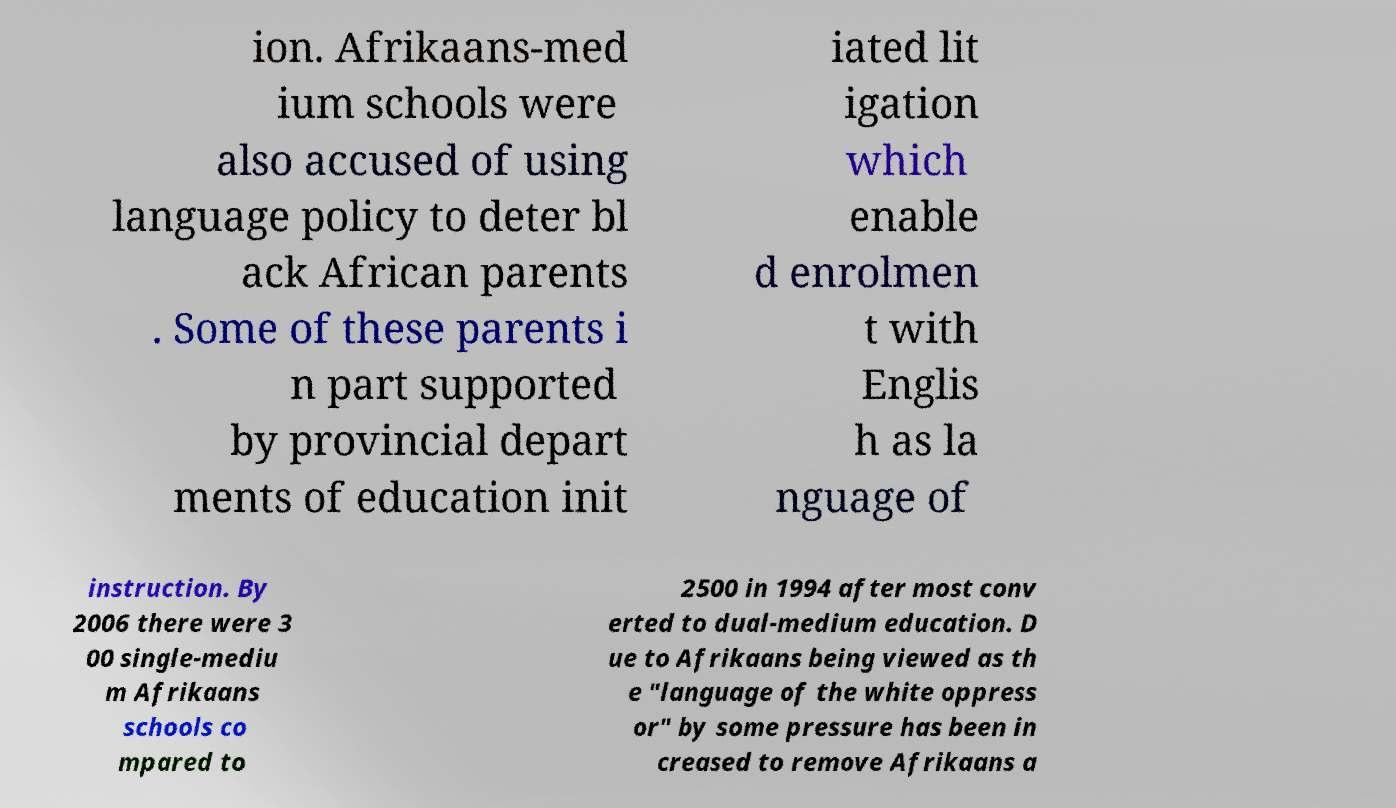Please read and relay the text visible in this image. What does it say? ion. Afrikaans-med ium schools were also accused of using language policy to deter bl ack African parents . Some of these parents i n part supported by provincial depart ments of education init iated lit igation which enable d enrolmen t with Englis h as la nguage of instruction. By 2006 there were 3 00 single-mediu m Afrikaans schools co mpared to 2500 in 1994 after most conv erted to dual-medium education. D ue to Afrikaans being viewed as th e "language of the white oppress or" by some pressure has been in creased to remove Afrikaans a 